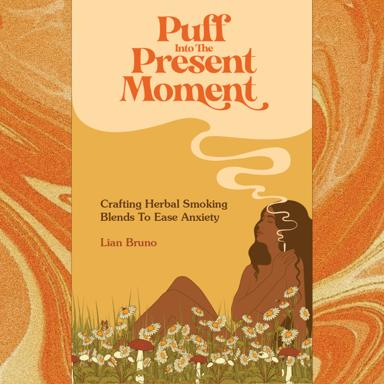What is the title of the book or article mentioned in the image? The book shown in the image is titled “Puff: Present Moment - Crafting Herbal Smoking Blends To Ease Anxiety” authored by Lian Bruno. It features a serene illustration of a woman surrounded by a natural setting, highlighting the book’s focus on natural remedies. 